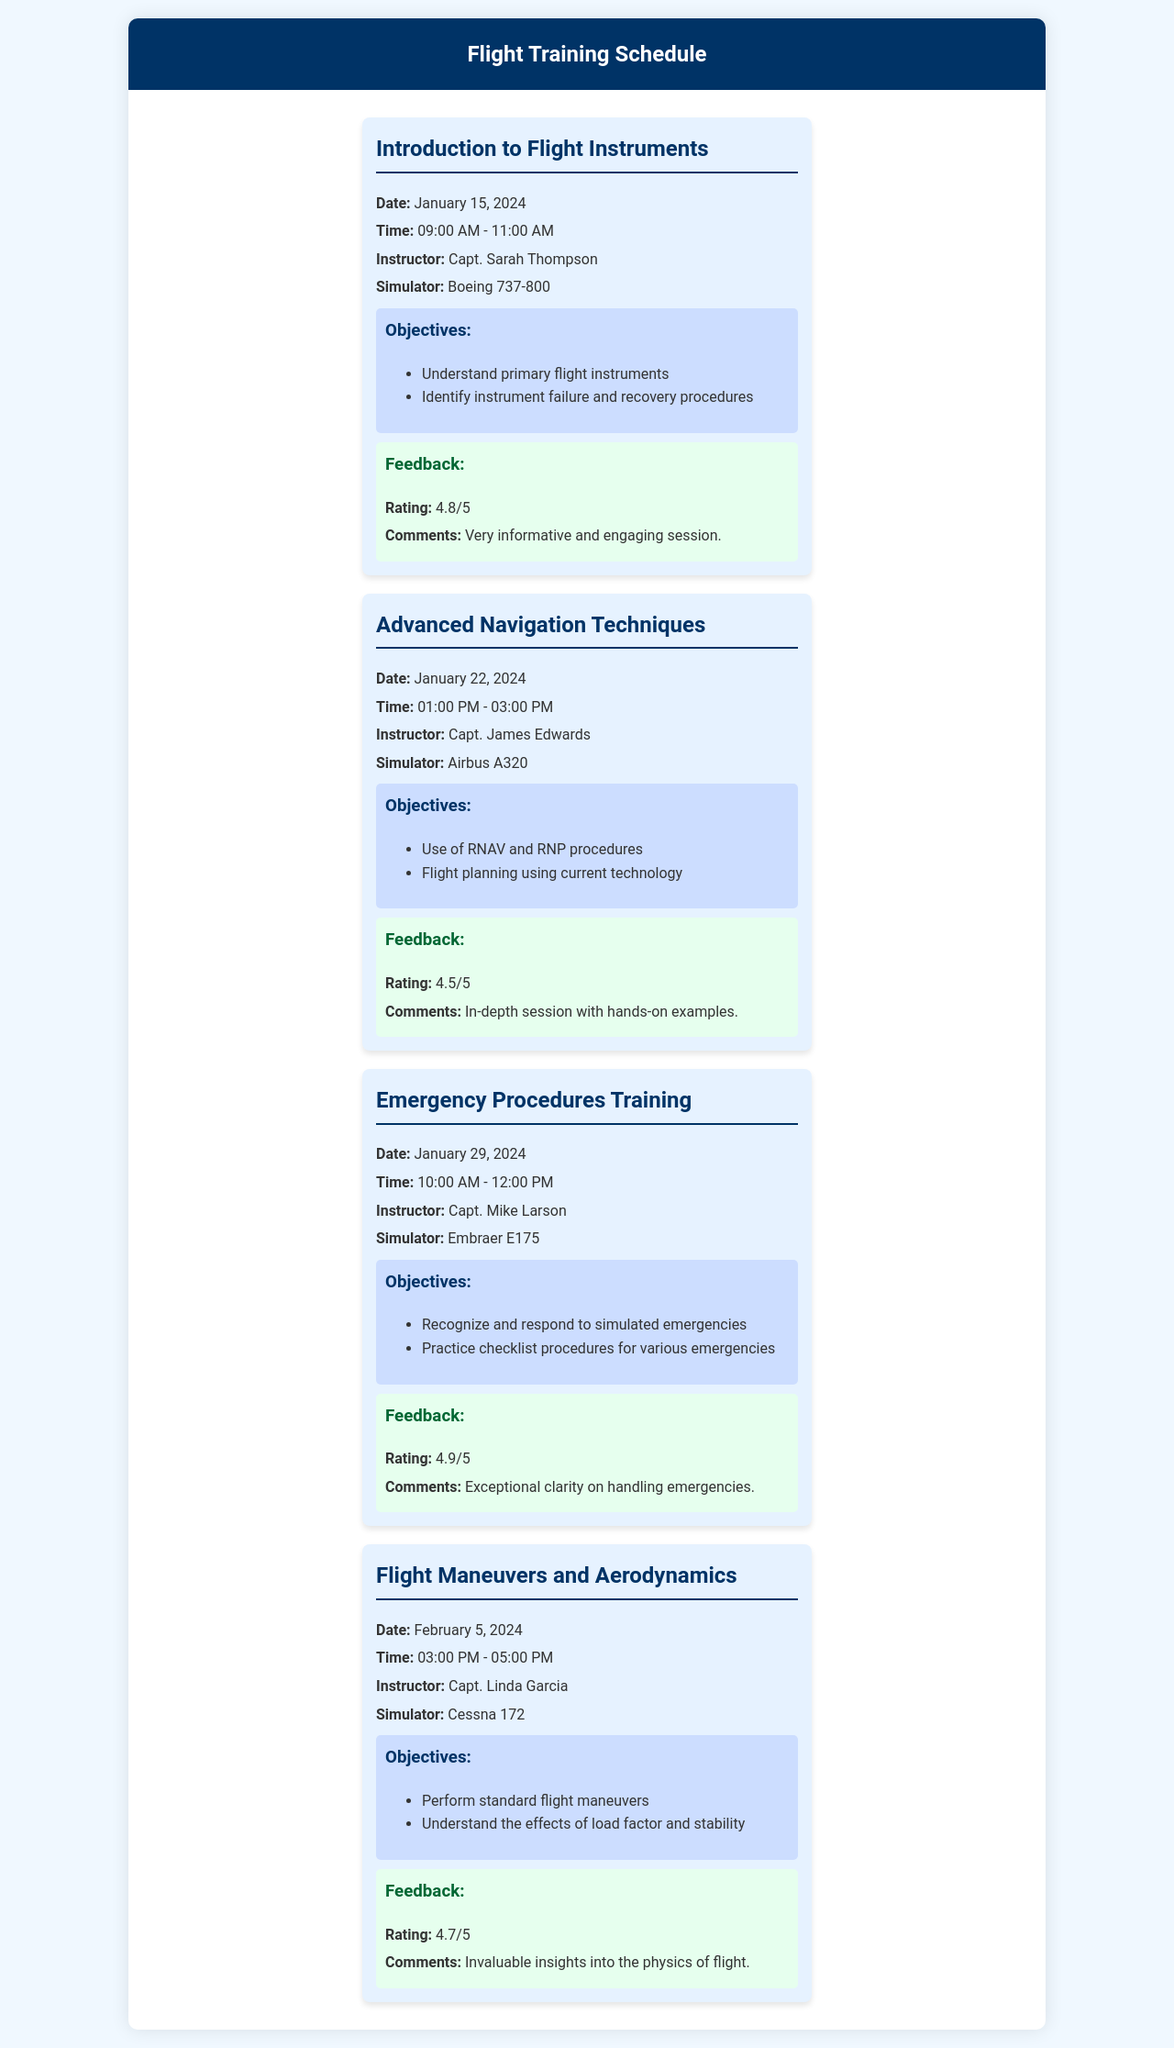What is the date of the "Introduction to Flight Instruments" session? The document states that this session is scheduled for January 15, 2024.
Answer: January 15, 2024 Who is the instructor for the "Advanced Navigation Techniques" session? The document lists Capt. James Edwards as the instructor for this session.
Answer: Capt. James Edwards What simulator is used for the "Emergency Procedures Training"? According to the document, the simulator used is the Embraer E175.
Answer: Embraer E175 What is the feedback rating for the "Flight Maneuvers and Aerodynamics" session? The document indicates that this session received a feedback rating of 4.7/5.
Answer: 4.7/5 How many objectives are listed for the "Introduction to Flight Instruments" session? The document shows two objectives listed for this session.
Answer: 2 Which session has the highest feedback rating? The "Emergency Procedures Training" session has the highest rating of 4.9/5 according to the document.
Answer: 4.9/5 What are the times for the "Advanced Navigation Techniques" training? The document shows that this training runs from 01:00 PM to 03:00 PM.
Answer: 01:00 PM - 03:00 PM What topic is covered in the session on February 5, 2024? The document states that Flight Maneuvers and Aerodynamics is the topic covered in this session.
Answer: Flight Maneuvers and Aerodynamics What color is the background for the flight training schedule? The background color of the document is a light blue, specifically #f0f8ff.
Answer: #f0f8ff 